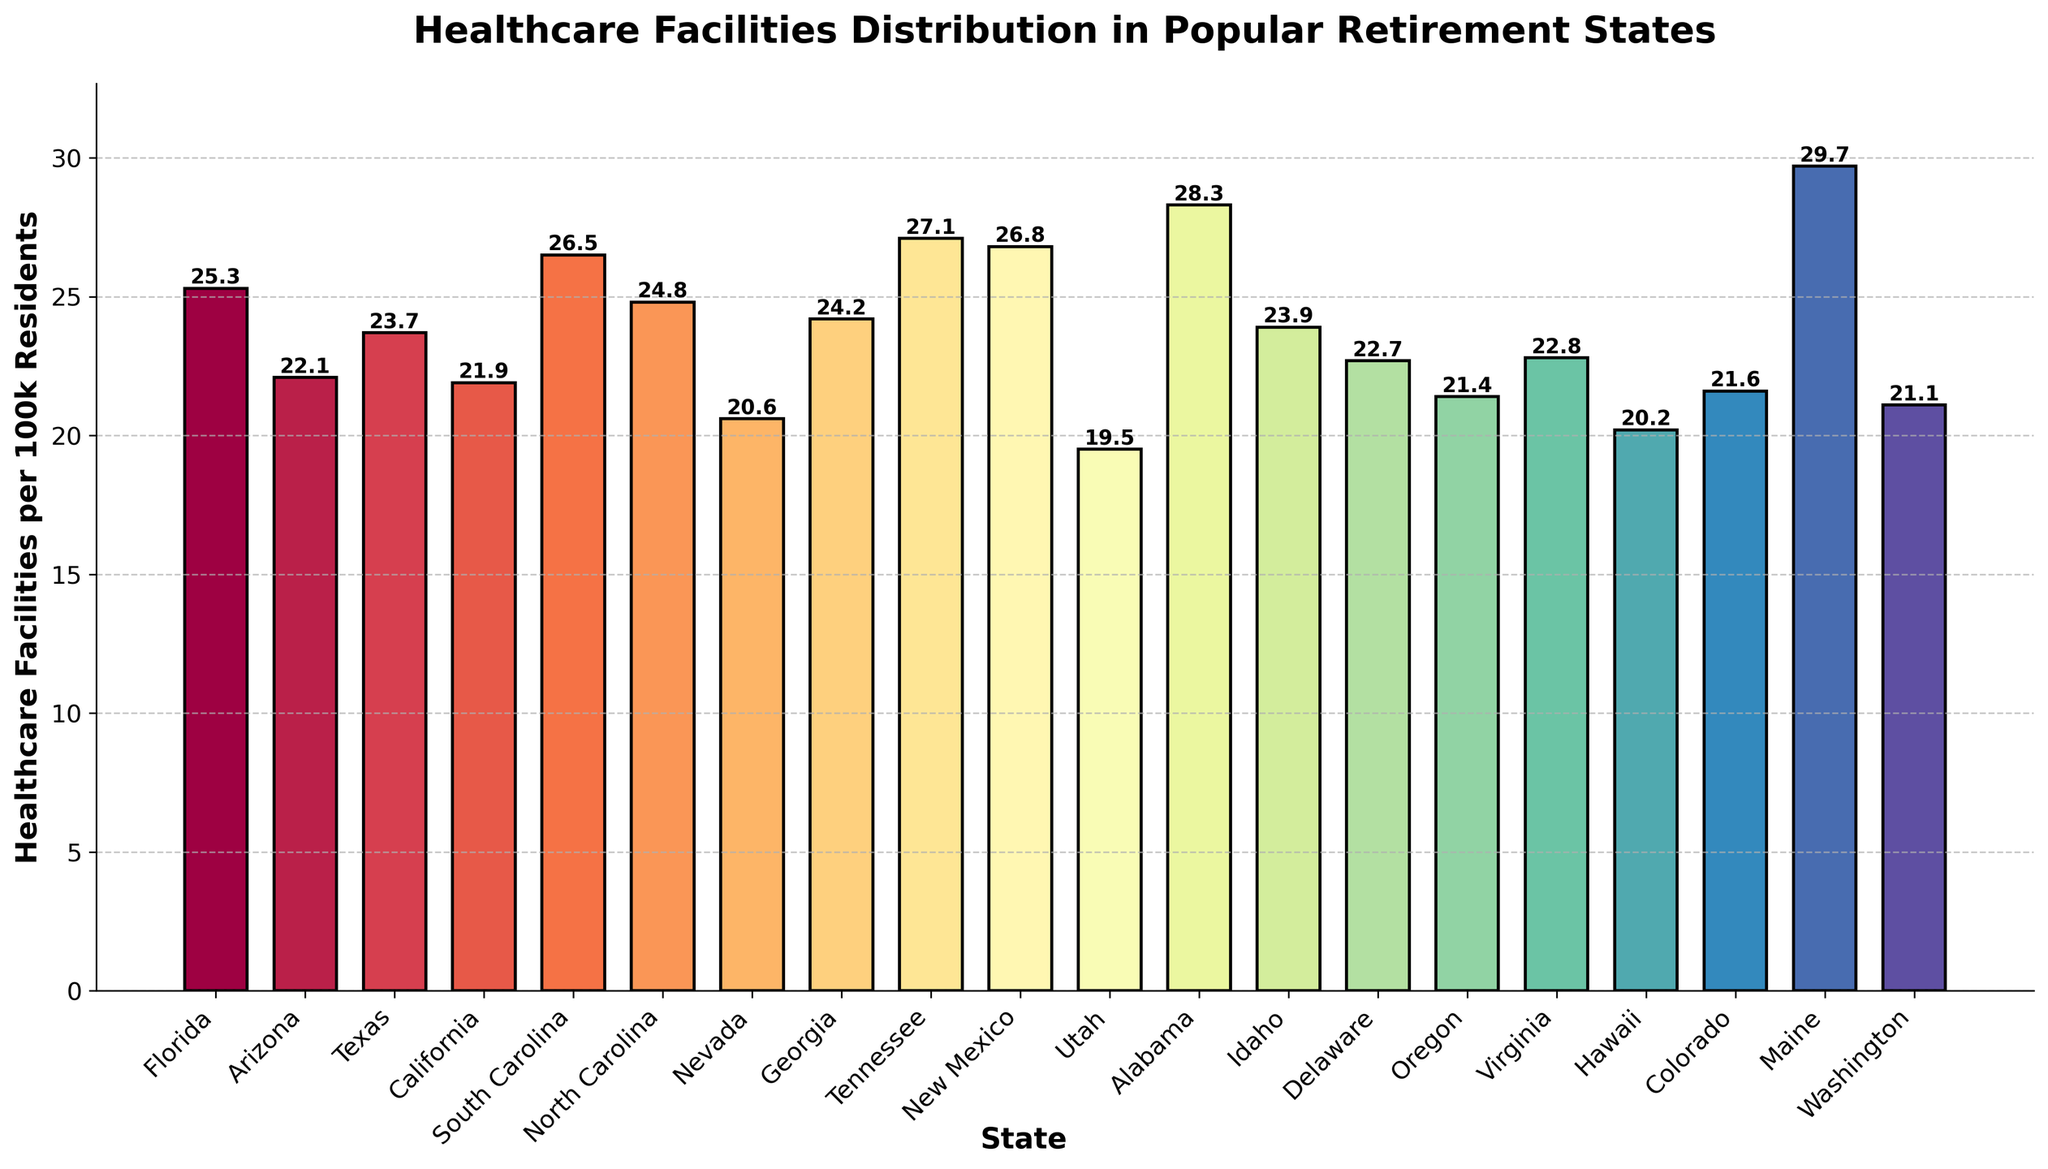How many states have more than 25 healthcare facilities per 100k residents? First, check which states have a number greater than 25. These states include: South Carolina (26.5), Tennessee (27.1), New Mexico (26.8), Alabama (28.3), and Maine (29.7). Count these states, resulting in 5 states.
Answer: 5 Which state has the lowest number of healthcare facilities per 100k residents? Identify the state with the shortest bar. Utah has the shortest bar with 19.5 healthcare facilities per 100k residents.
Answer: Utah What is the difference in healthcare facilities per 100k residents between Maine and Utah? Look at the heights of Maine and Utah. Maine has 29.7 and Utah has 19.5. Subtract Utah's value from Maine's value: 29.7 - 19.5 = 10.2.
Answer: 10.2 Are there more states with healthcare facilities per 100k residents above or below 22.5? Count the states above 22.5: Florida, Arizona, Texas, South Carolina, North Carolina, Georgia, Tennessee, New Mexico, Alabama, Delaware, Idaho, Virginia, and Maine (13 states). Count the states below 22.5: California, Nevada, Utah, Hawaii, Colorado, Oregon, and Washington (7 states).
Answer: More above Which states have healthcare facilities per 100k residents exactly between 22 and 23? Identify the states with bars between 22 and 23. Arizona (22.1), California (21.9), Delaware (22.7), and Virginia (22.8) meet this criterion.
Answer: Arizona, California, Delaware, Virginia What is the average number of healthcare facilities per 100k residents in the top 3 states? Identify the top 3 states by the tallest bars: Maine (29.7), Alabama (28.3), and Tennessee (27.1). Add these values together: 29.7 + 28.3 + 27.1 = 85.1. Divide by 3: 85.1 / 3 = 28.37.
Answer: 28.37 Which state has a similar number of healthcare facilities per 100k residents to Georgia? Georgia has 24.2 healthcare facilities per 100k residents. North Carolina has 24.8, which is close to Georgia's number.
Answer: North Carolina Are there any states with healthcare facilities per 100k residents very close to 22.0? Yes, identify the states with bars close to 22.0. Arizona (22.1) and California (21.9) are close to this number.
Answer: Arizona, California How do the healthcare facilities in Florida compare to those in Texas? Florida has 25.3 healthcare facilities per 100k residents, and Texas has 23.7. Florida has more healthcare facilities per 100k residents than Texas.
Answer: Florida has more Which of the following states have over 24 healthcare facilities per 100k residents: Florida, Texas, Nevada, Alabama? Check the values for each state: Florida (25.3), Texas (23.7), Nevada (20.6), and Alabama (28.3). The states with over 24 healthcare facilities per 100k residents are Florida and Alabama.
Answer: Florida, Alabama 